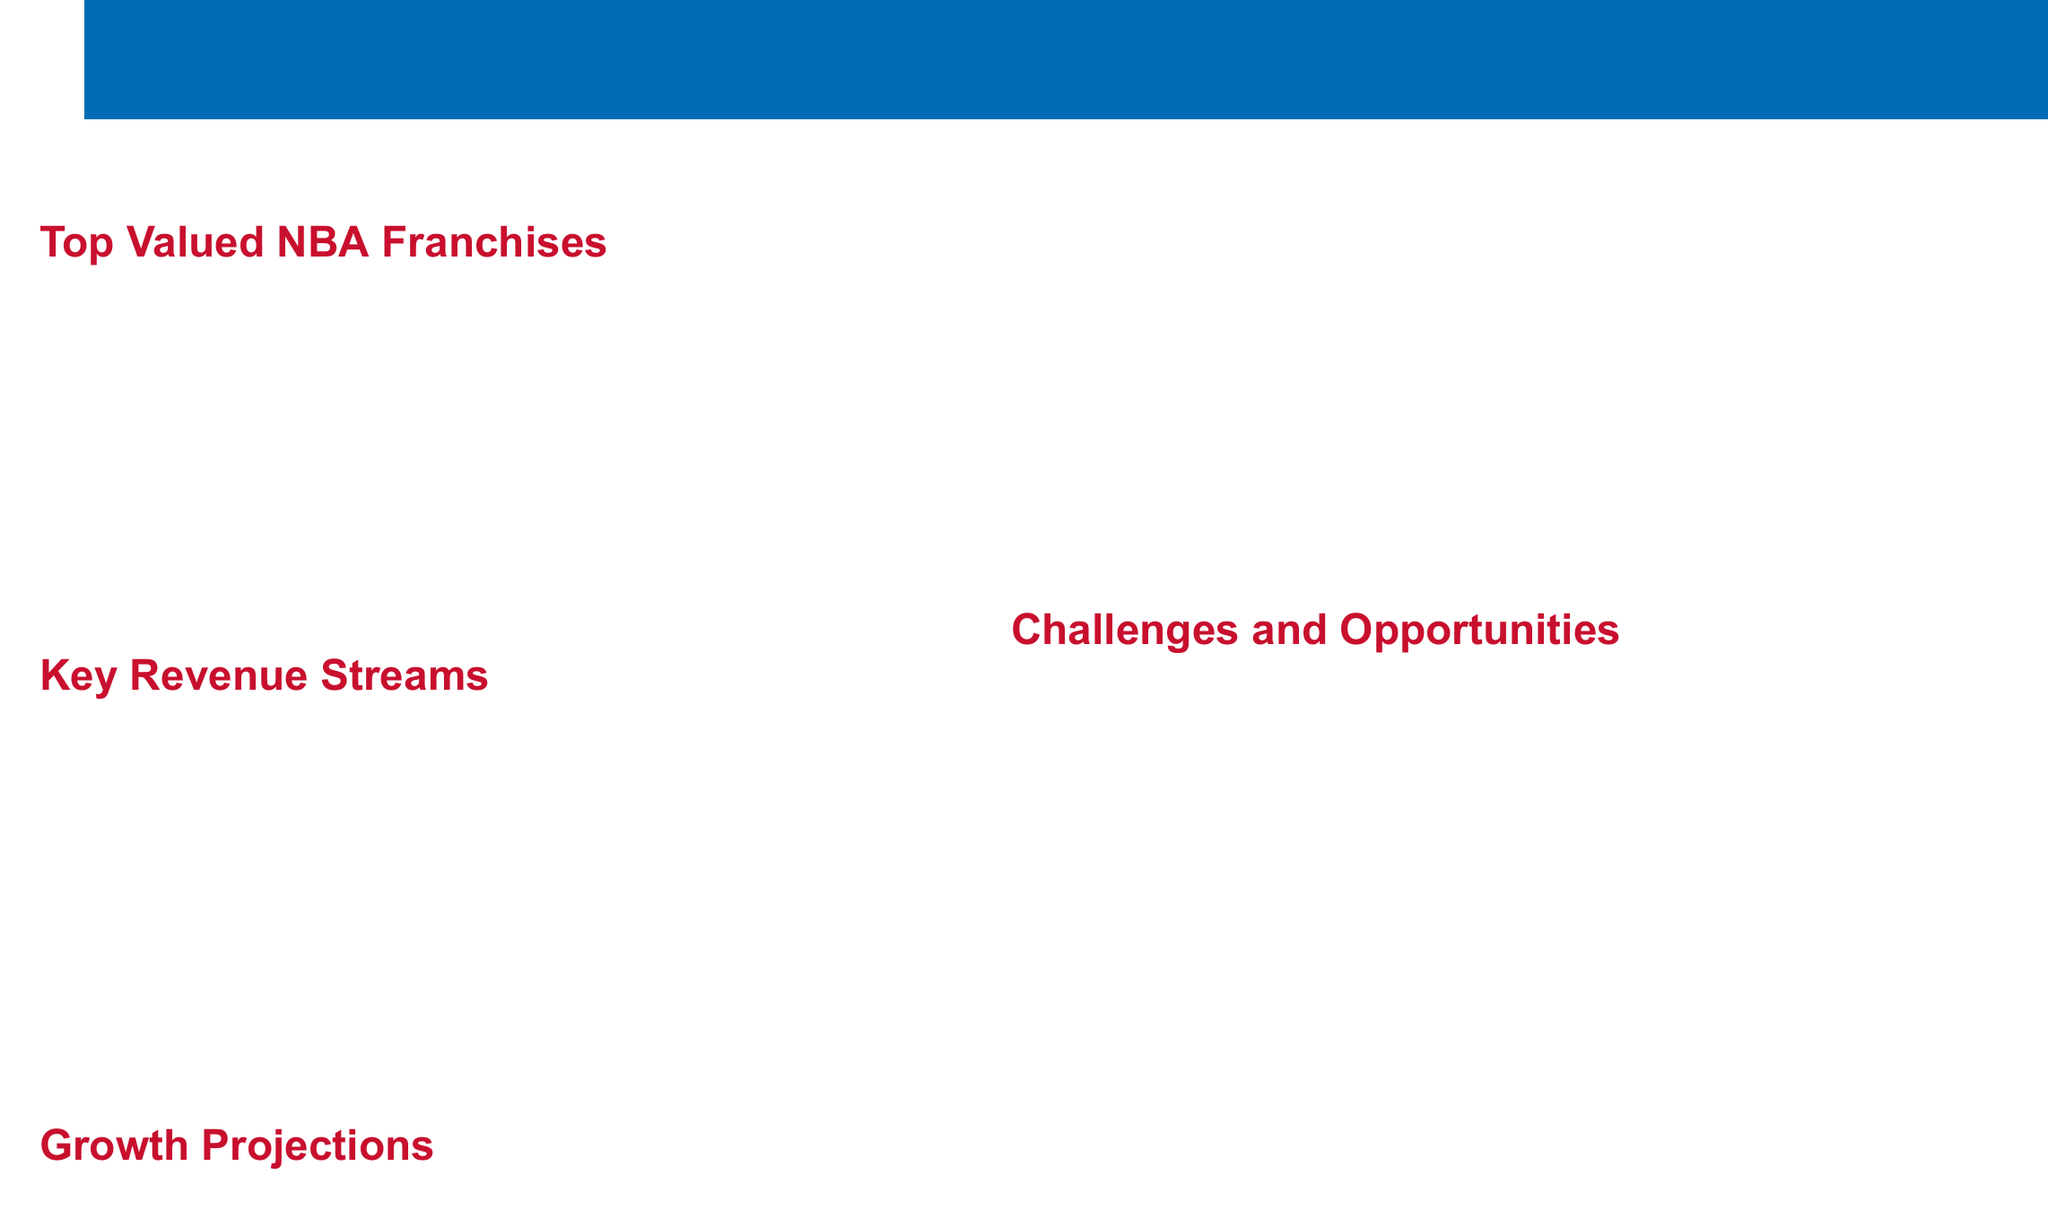What is the value of the Golden State Warriors? The document states that the Golden State Warriors are valued at $7.7 billion, making them the most valuable franchise in the NBA.
Answer: $7.7 billion What is the total revenue from media rights for the 2021-2022 season? According to the document, the media rights generate $2.66 billion annually for the league.
Answer: $2.66 billion Which franchise is valued at $4.6 billion? The Chicago Bulls are listed in the document as having a franchise value of $4.6 billion.
Answer: Chicago Bulls What is the expected annual growth rate over the next five years? The document mentions an expected annual growth rate of 6-8% for NBA revenues over the next five years.
Answer: 6-8% What revenue stream generated $1.5 billion for the league? The document indicates that merchandise sales accounted for $1.5 billion in revenue league-wide.
Answer: Merchandise What major challenge does the NBA face post-pandemic? The document states that post-pandemic recovery and fan attendance is a challenge for the league.
Answer: Fan attendance How much could potential new expansion teams add to league value? The document estimates that new expansion teams could add between $6-8 billion to the overall league value.
Answer: $6-8 billion What company has naming rights to the Lakers' arena? The document specifies that Crypto.com Arena is the name of the Lakers' arena, which has a naming rights deal worth $700 million over 20 years.
Answer: Crypto.com What is the projected league-wide revenue for the 2022-2023 season? The document forecasts a projected league-wide revenue of $10 billion for the 2022-2023 season.
Answer: $10 billion 